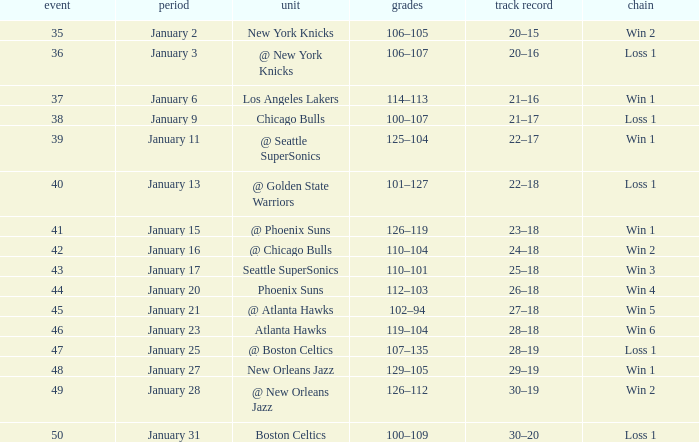What is the Team in Game 38? Chicago Bulls. 